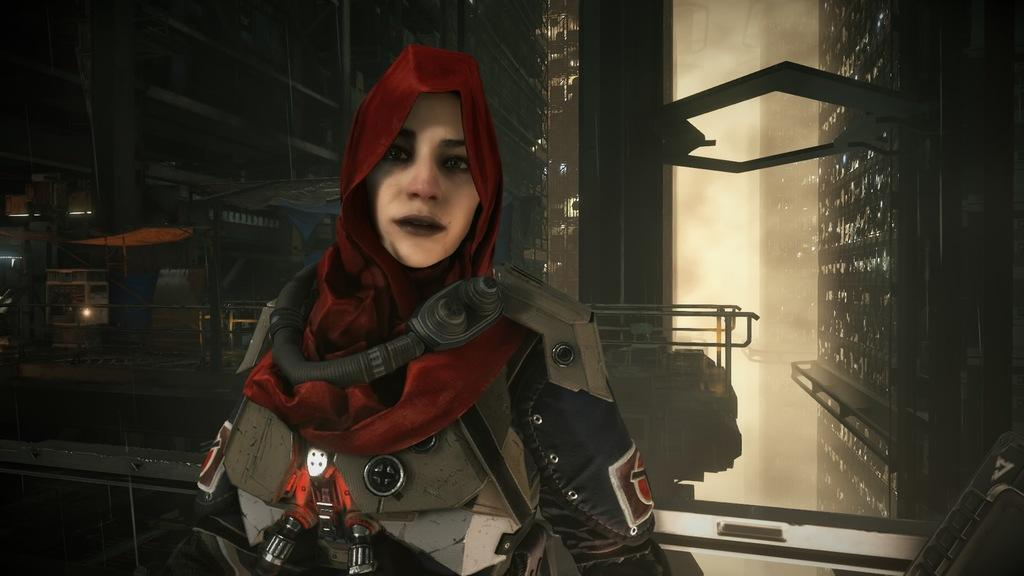Who is present in the image? There is a woman in the image. What can be seen in the background of the image? There are buildings, lights, railings, and tents in the background of the image. What type of sweater is the woman wearing in the image? The provided facts do not mention any clothing details, so we cannot determine the type of sweater the woman is wearing. 